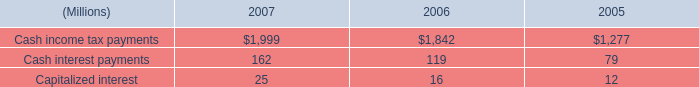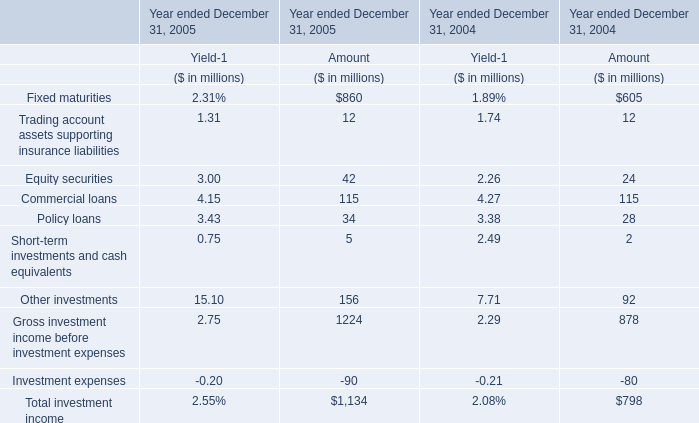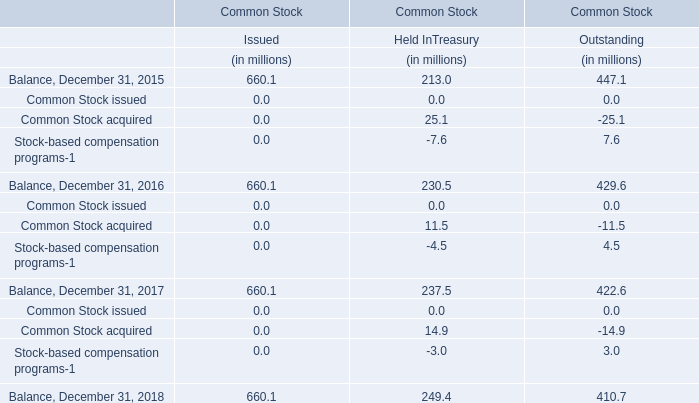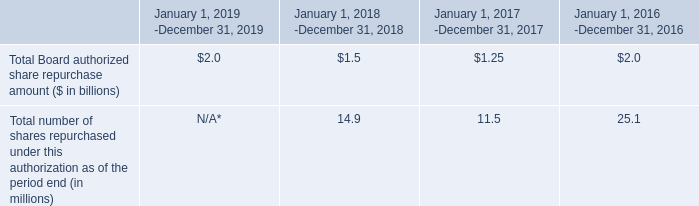What was the total amount of investment income excluding those investment income greater than 100 in 2005 ? (in million) 
Computations: ((((12 + 42) + 34) + 5) - 90)
Answer: 3.0. 